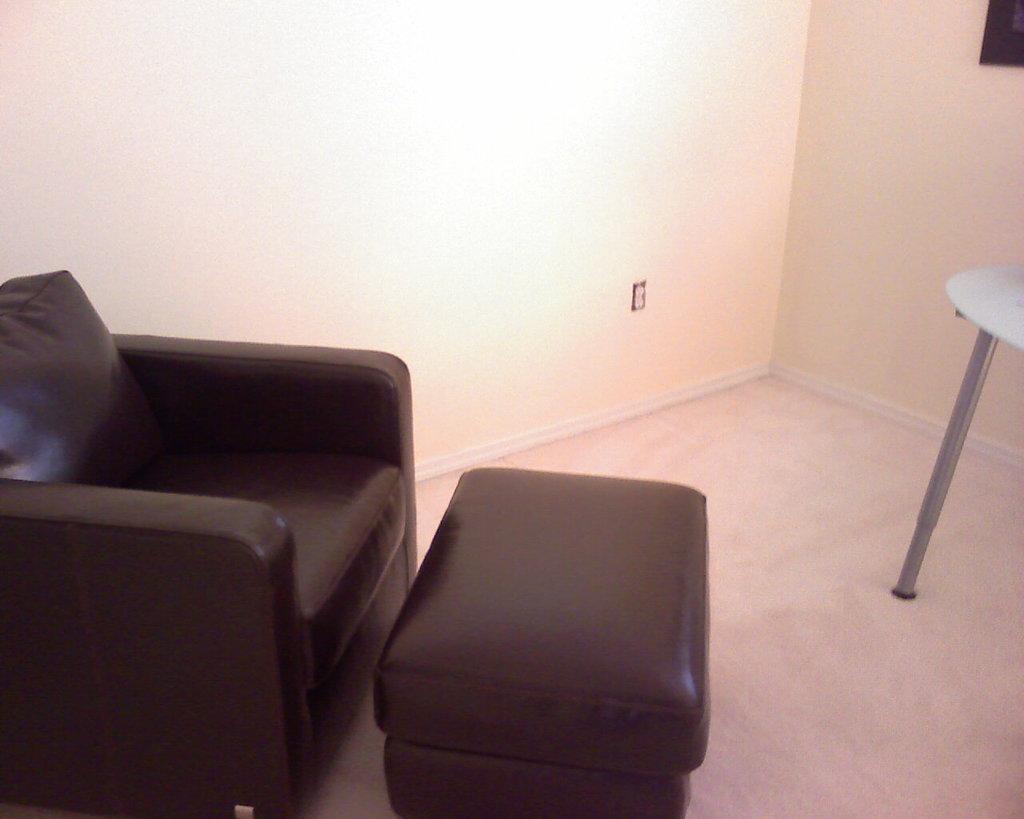Please provide a concise description of this image. This a picture consist of a sofa set on the left side with black color and in front of the sofa set there is a small table and kept on the floor and there is a wall visible on the middle. 